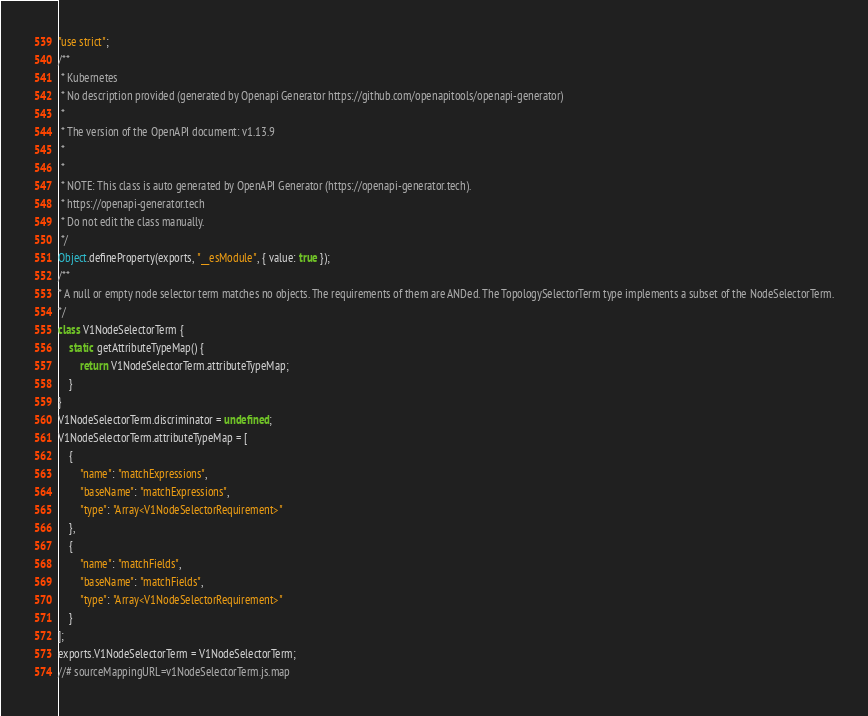Convert code to text. <code><loc_0><loc_0><loc_500><loc_500><_JavaScript_>"use strict";
/**
 * Kubernetes
 * No description provided (generated by Openapi Generator https://github.com/openapitools/openapi-generator)
 *
 * The version of the OpenAPI document: v1.13.9
 *
 *
 * NOTE: This class is auto generated by OpenAPI Generator (https://openapi-generator.tech).
 * https://openapi-generator.tech
 * Do not edit the class manually.
 */
Object.defineProperty(exports, "__esModule", { value: true });
/**
* A null or empty node selector term matches no objects. The requirements of them are ANDed. The TopologySelectorTerm type implements a subset of the NodeSelectorTerm.
*/
class V1NodeSelectorTerm {
    static getAttributeTypeMap() {
        return V1NodeSelectorTerm.attributeTypeMap;
    }
}
V1NodeSelectorTerm.discriminator = undefined;
V1NodeSelectorTerm.attributeTypeMap = [
    {
        "name": "matchExpressions",
        "baseName": "matchExpressions",
        "type": "Array<V1NodeSelectorRequirement>"
    },
    {
        "name": "matchFields",
        "baseName": "matchFields",
        "type": "Array<V1NodeSelectorRequirement>"
    }
];
exports.V1NodeSelectorTerm = V1NodeSelectorTerm;
//# sourceMappingURL=v1NodeSelectorTerm.js.map</code> 